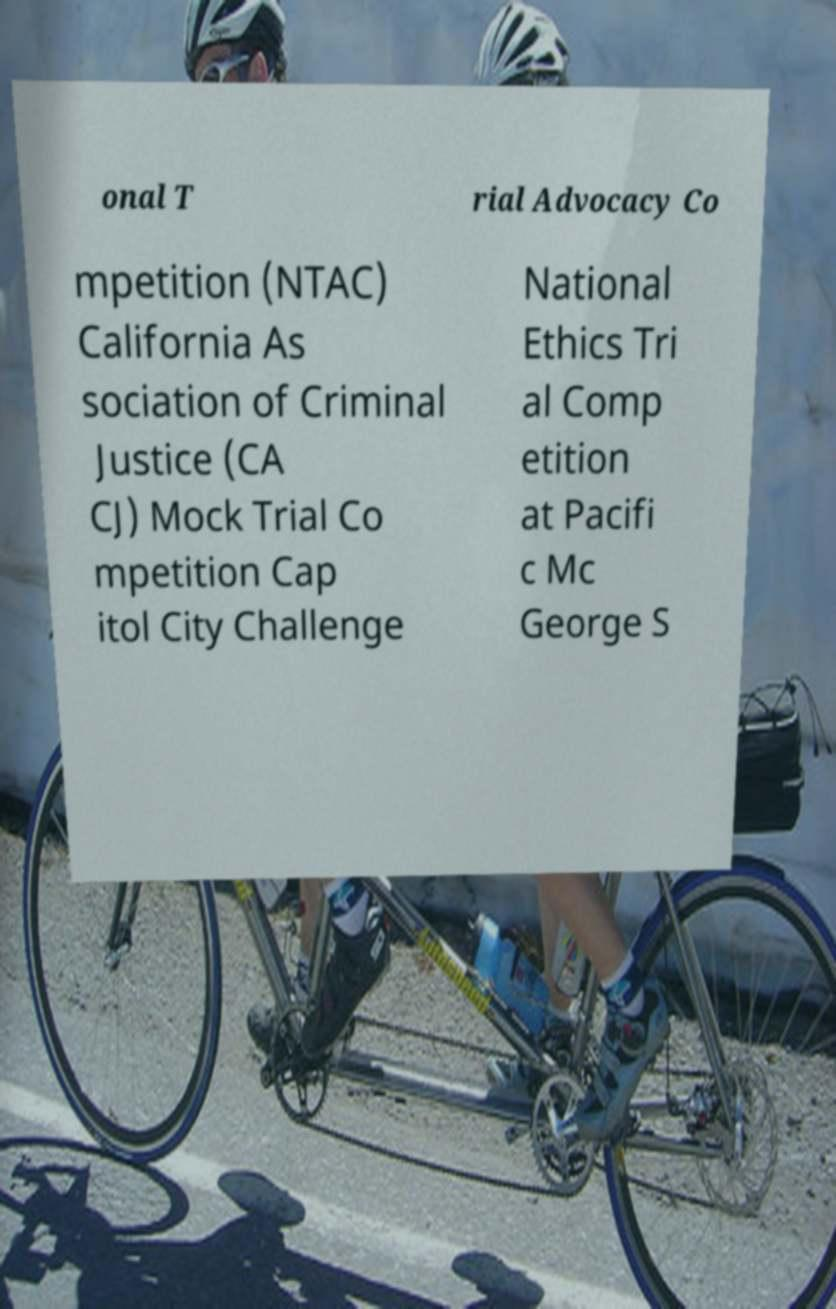Please identify and transcribe the text found in this image. onal T rial Advocacy Co mpetition (NTAC) California As sociation of Criminal Justice (CA CJ) Mock Trial Co mpetition Cap itol City Challenge National Ethics Tri al Comp etition at Pacifi c Mc George S 